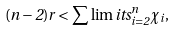<formula> <loc_0><loc_0><loc_500><loc_500>( n - 2 ) r < \sum \lim i t s _ { i = 2 } ^ { n } \chi _ { i } ,</formula> 